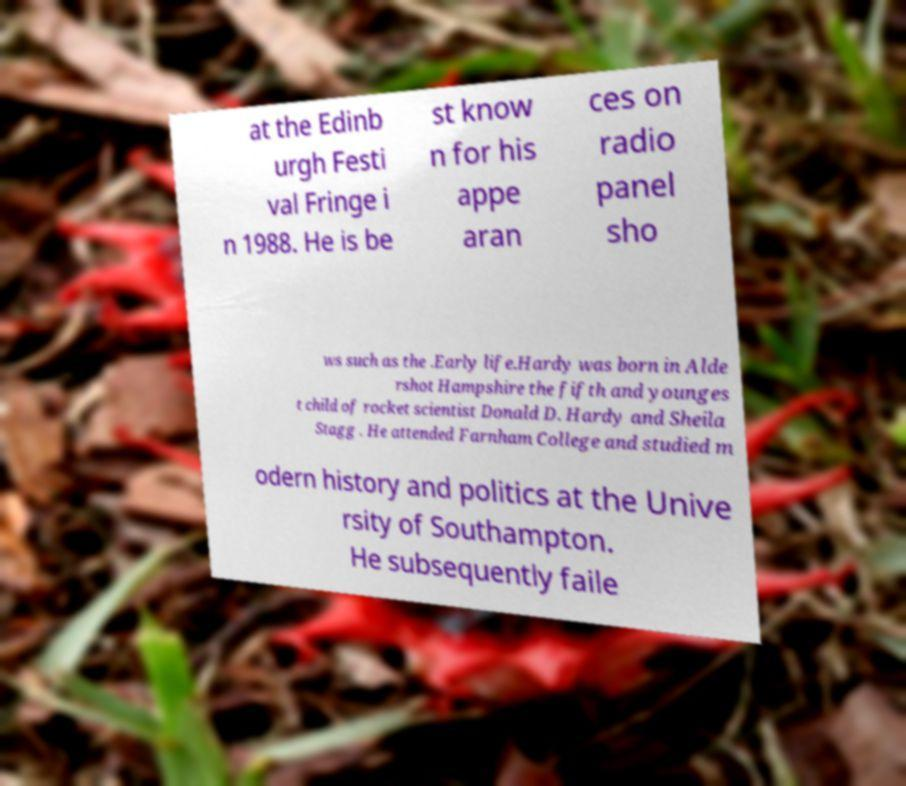Could you extract and type out the text from this image? at the Edinb urgh Festi val Fringe i n 1988. He is be st know n for his appe aran ces on radio panel sho ws such as the .Early life.Hardy was born in Alde rshot Hampshire the fifth and younges t child of rocket scientist Donald D. Hardy and Sheila Stagg . He attended Farnham College and studied m odern history and politics at the Unive rsity of Southampton. He subsequently faile 